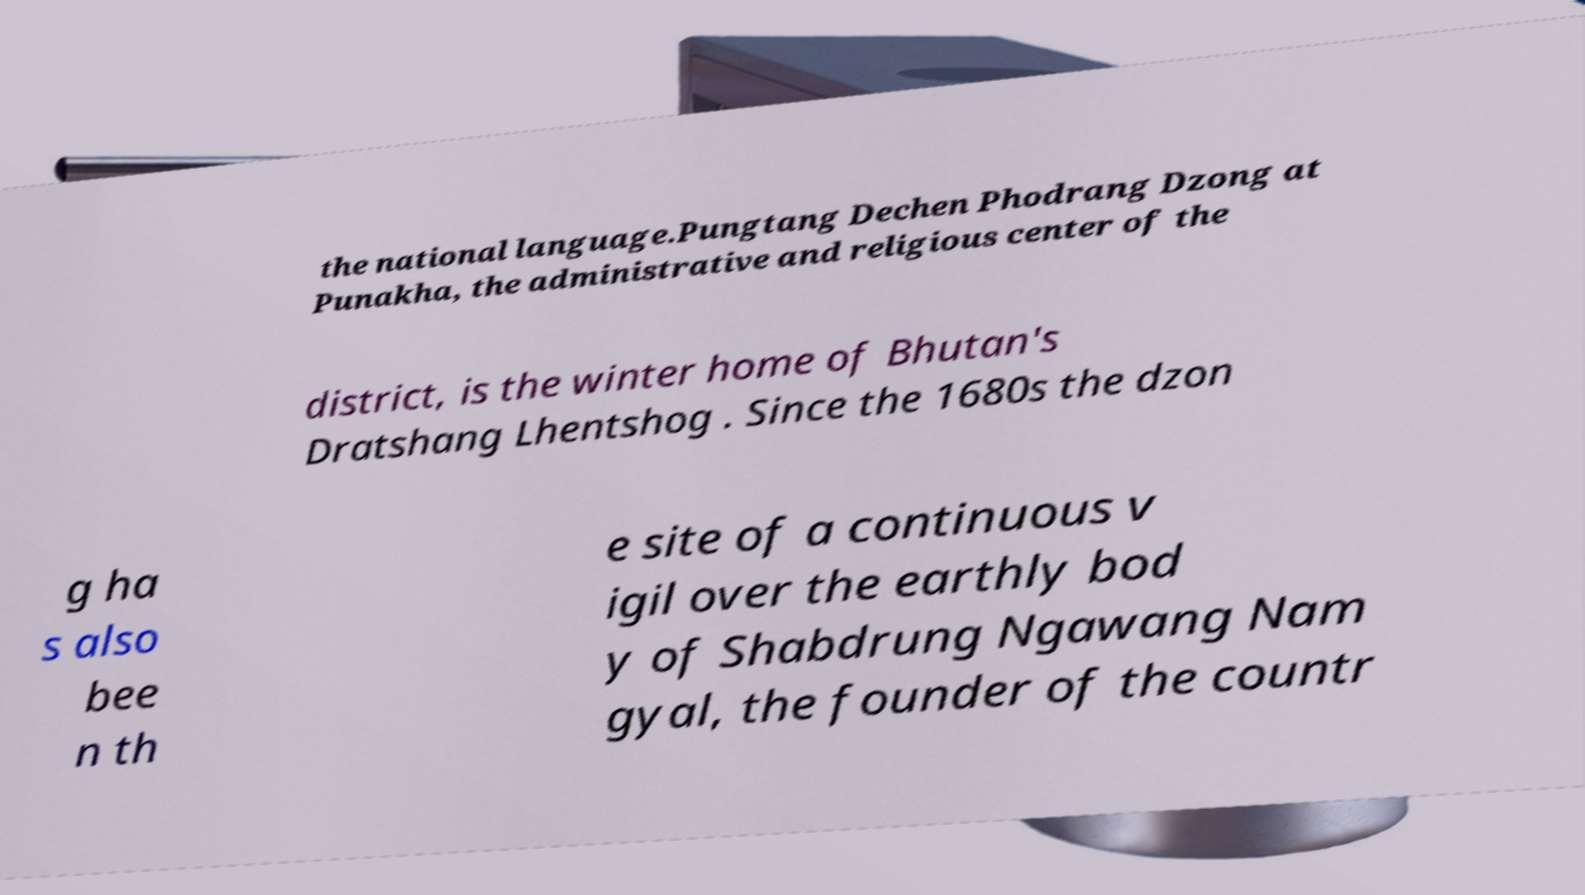For documentation purposes, I need the text within this image transcribed. Could you provide that? the national language.Pungtang Dechen Phodrang Dzong at Punakha, the administrative and religious center of the district, is the winter home of Bhutan's Dratshang Lhentshog . Since the 1680s the dzon g ha s also bee n th e site of a continuous v igil over the earthly bod y of Shabdrung Ngawang Nam gyal, the founder of the countr 